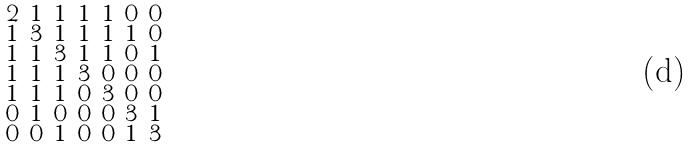<formula> <loc_0><loc_0><loc_500><loc_500>\begin{smallmatrix} 2 & 1 & 1 & 1 & 1 & 0 & 0 \\ 1 & 3 & 1 & 1 & 1 & 1 & 0 \\ 1 & 1 & 3 & 1 & 1 & 0 & 1 \\ 1 & 1 & 1 & 3 & 0 & 0 & 0 \\ 1 & 1 & 1 & 0 & 3 & 0 & 0 \\ 0 & 1 & 0 & 0 & 0 & 3 & 1 \\ 0 & 0 & 1 & 0 & 0 & 1 & 3 \end{smallmatrix}</formula> 